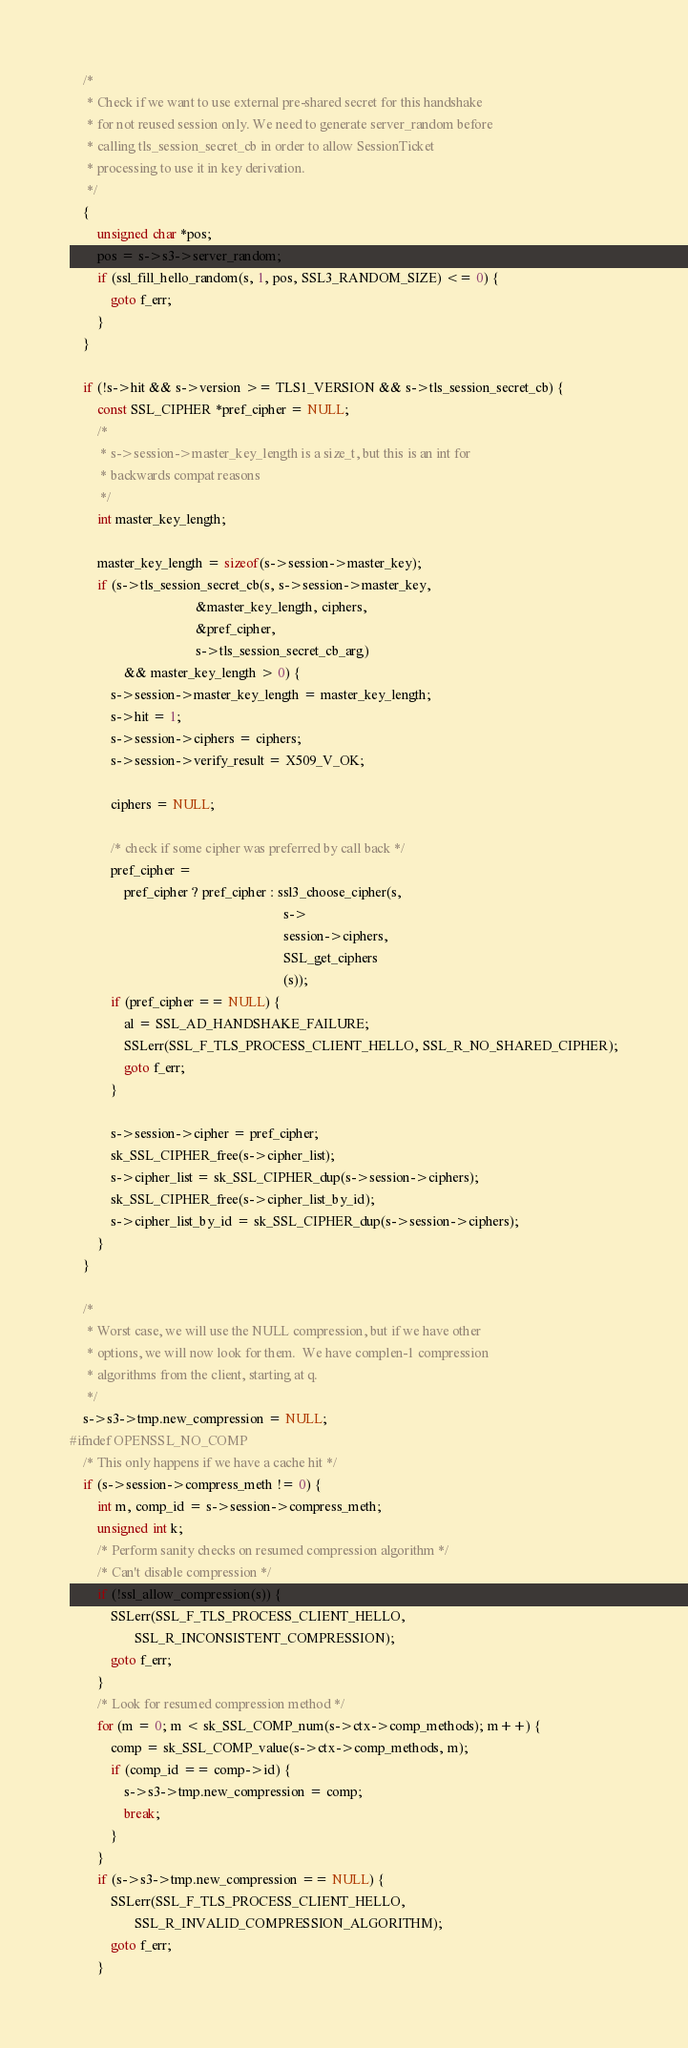<code> <loc_0><loc_0><loc_500><loc_500><_C_>
    /*
     * Check if we want to use external pre-shared secret for this handshake
     * for not reused session only. We need to generate server_random before
     * calling tls_session_secret_cb in order to allow SessionTicket
     * processing to use it in key derivation.
     */
    {
        unsigned char *pos;
        pos = s->s3->server_random;
        if (ssl_fill_hello_random(s, 1, pos, SSL3_RANDOM_SIZE) <= 0) {
            goto f_err;
        }
    }

    if (!s->hit && s->version >= TLS1_VERSION && s->tls_session_secret_cb) {
        const SSL_CIPHER *pref_cipher = NULL;
        /*
         * s->session->master_key_length is a size_t, but this is an int for
         * backwards compat reasons
         */
        int master_key_length;

        master_key_length = sizeof(s->session->master_key);
        if (s->tls_session_secret_cb(s, s->session->master_key,
                                     &master_key_length, ciphers,
                                     &pref_cipher,
                                     s->tls_session_secret_cb_arg)
                && master_key_length > 0) {
            s->session->master_key_length = master_key_length;
            s->hit = 1;
            s->session->ciphers = ciphers;
            s->session->verify_result = X509_V_OK;

            ciphers = NULL;

            /* check if some cipher was preferred by call back */
            pref_cipher =
                pref_cipher ? pref_cipher : ssl3_choose_cipher(s,
                                                               s->
                                                               session->ciphers,
                                                               SSL_get_ciphers
                                                               (s));
            if (pref_cipher == NULL) {
                al = SSL_AD_HANDSHAKE_FAILURE;
                SSLerr(SSL_F_TLS_PROCESS_CLIENT_HELLO, SSL_R_NO_SHARED_CIPHER);
                goto f_err;
            }

            s->session->cipher = pref_cipher;
            sk_SSL_CIPHER_free(s->cipher_list);
            s->cipher_list = sk_SSL_CIPHER_dup(s->session->ciphers);
            sk_SSL_CIPHER_free(s->cipher_list_by_id);
            s->cipher_list_by_id = sk_SSL_CIPHER_dup(s->session->ciphers);
        }
    }

    /*
     * Worst case, we will use the NULL compression, but if we have other
     * options, we will now look for them.  We have complen-1 compression
     * algorithms from the client, starting at q.
     */
    s->s3->tmp.new_compression = NULL;
#ifndef OPENSSL_NO_COMP
    /* This only happens if we have a cache hit */
    if (s->session->compress_meth != 0) {
        int m, comp_id = s->session->compress_meth;
        unsigned int k;
        /* Perform sanity checks on resumed compression algorithm */
        /* Can't disable compression */
        if (!ssl_allow_compression(s)) {
            SSLerr(SSL_F_TLS_PROCESS_CLIENT_HELLO,
                   SSL_R_INCONSISTENT_COMPRESSION);
            goto f_err;
        }
        /* Look for resumed compression method */
        for (m = 0; m < sk_SSL_COMP_num(s->ctx->comp_methods); m++) {
            comp = sk_SSL_COMP_value(s->ctx->comp_methods, m);
            if (comp_id == comp->id) {
                s->s3->tmp.new_compression = comp;
                break;
            }
        }
        if (s->s3->tmp.new_compression == NULL) {
            SSLerr(SSL_F_TLS_PROCESS_CLIENT_HELLO,
                   SSL_R_INVALID_COMPRESSION_ALGORITHM);
            goto f_err;
        }</code> 